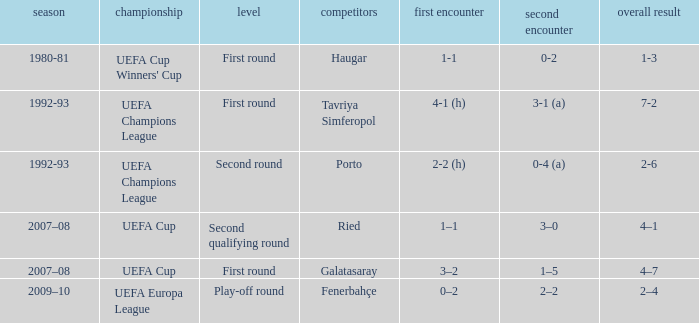 what's the competition where 1st leg is 4-1 (h) UEFA Champions League. 